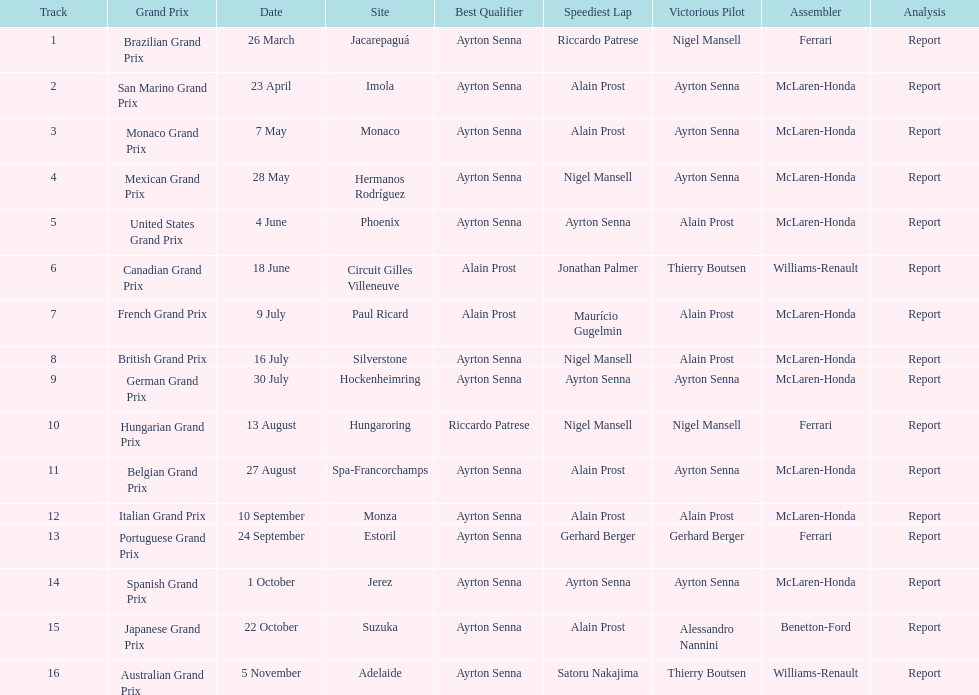What was the only grand prix to be won by benneton-ford? Japanese Grand Prix. 